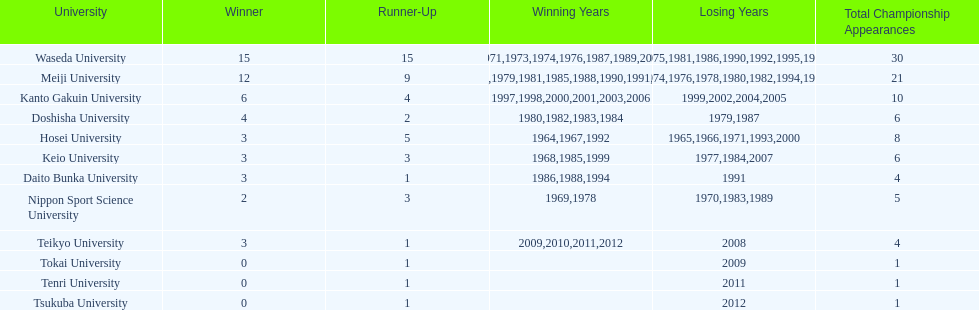How many championships does nippon sport science university have 2. 